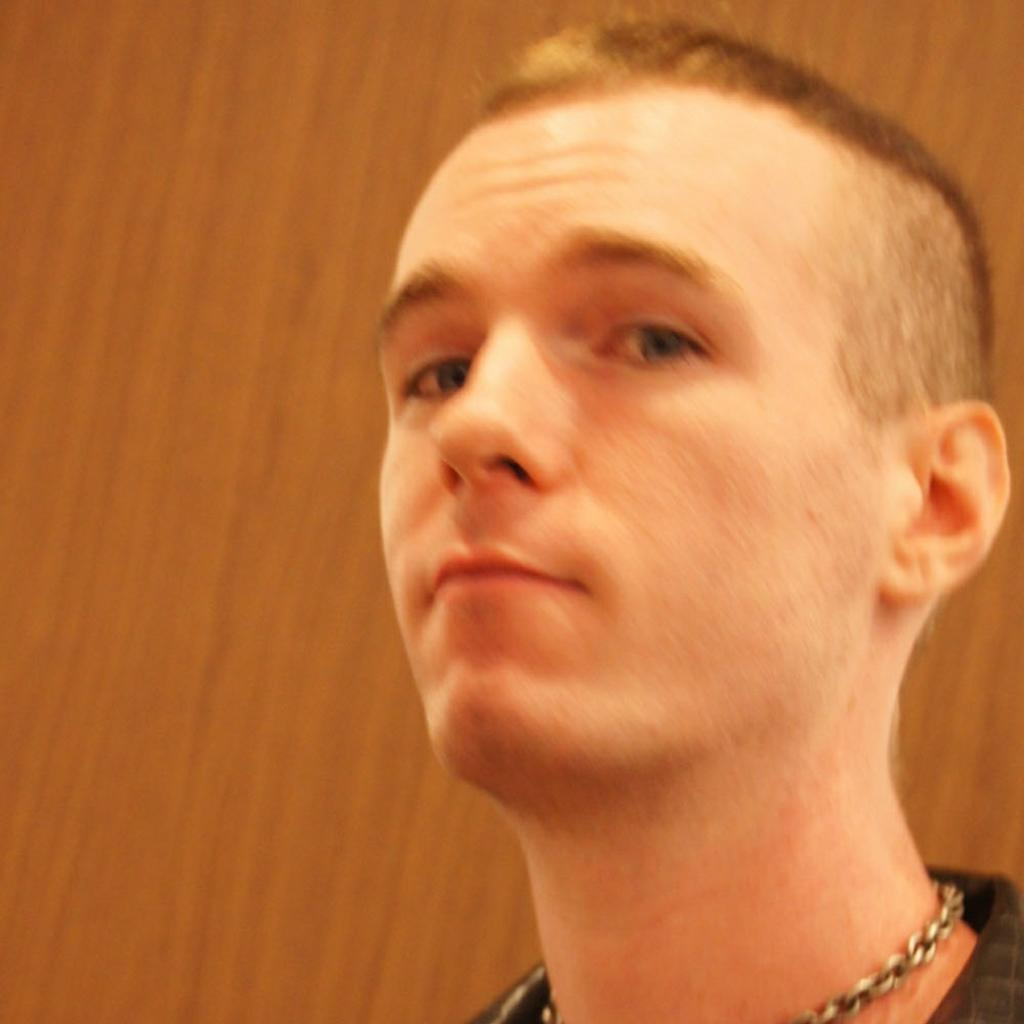What is the main subject of the image? The main subject of the image is a person's face. Can you describe any accessories or items the person is wearing in the image? Yes, there is a chain around the person's neck in the image. Is the person in the image stuck in quicksand? There is no indication of quicksand in the image, as it only features a person's face and a chain around their neck. 